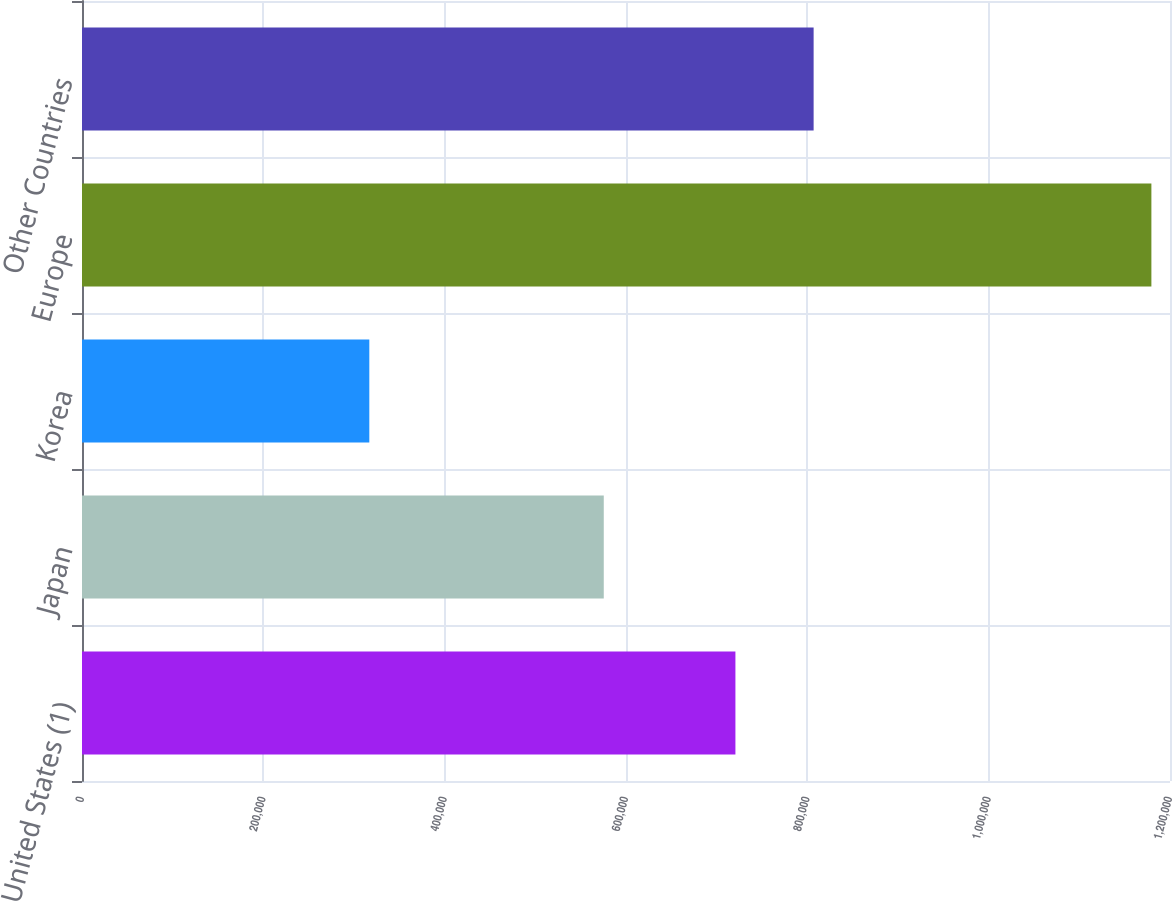Convert chart. <chart><loc_0><loc_0><loc_500><loc_500><bar_chart><fcel>United States (1)<fcel>Japan<fcel>Korea<fcel>Europe<fcel>Other Countries<nl><fcel>720679<fcel>575479<fcel>316893<fcel>1.17947e+06<fcel>806937<nl></chart> 